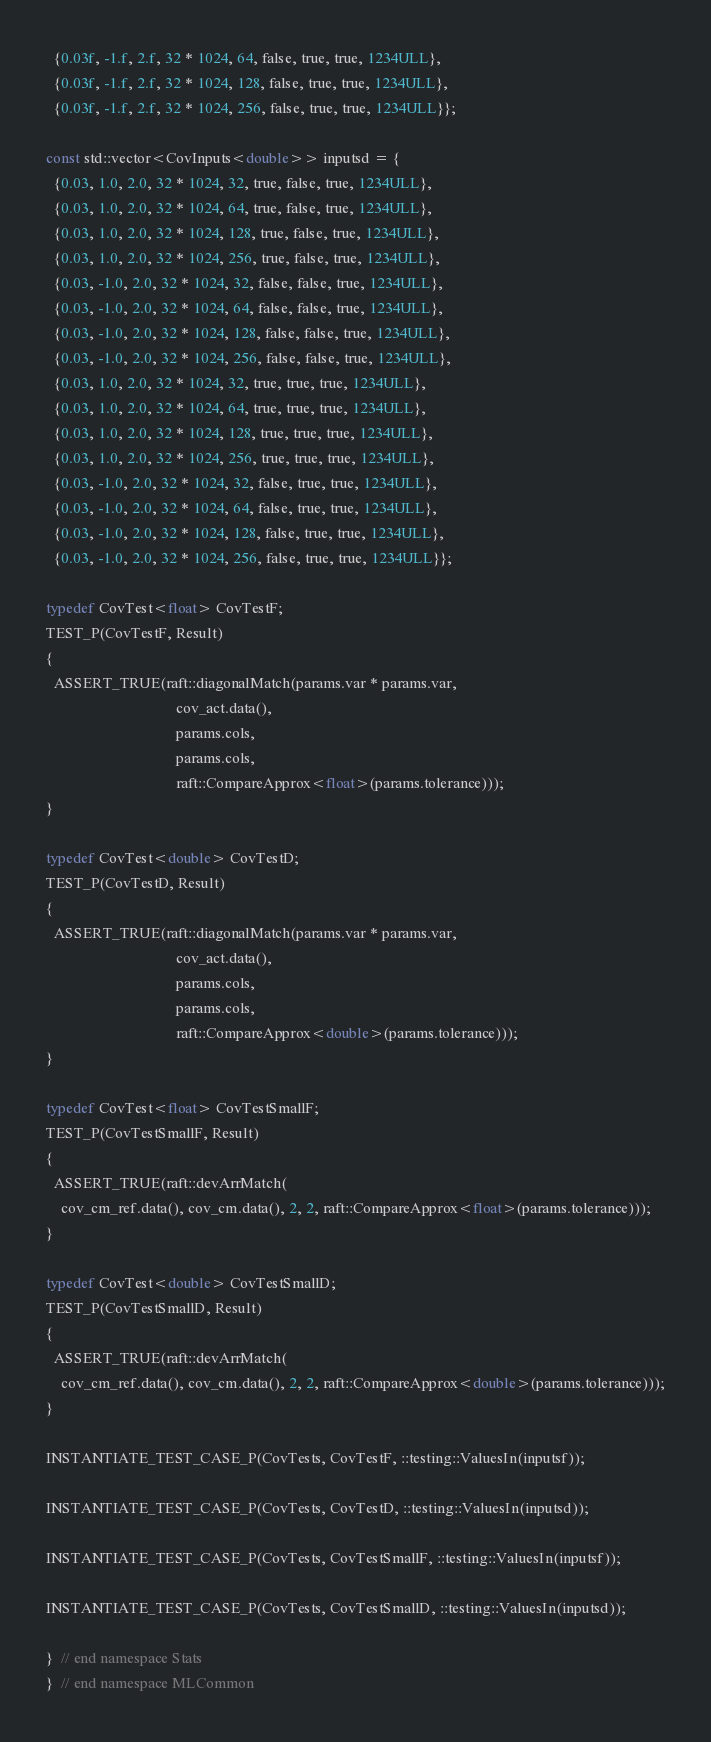<code> <loc_0><loc_0><loc_500><loc_500><_Cuda_>  {0.03f, -1.f, 2.f, 32 * 1024, 64, false, true, true, 1234ULL},
  {0.03f, -1.f, 2.f, 32 * 1024, 128, false, true, true, 1234ULL},
  {0.03f, -1.f, 2.f, 32 * 1024, 256, false, true, true, 1234ULL}};

const std::vector<CovInputs<double>> inputsd = {
  {0.03, 1.0, 2.0, 32 * 1024, 32, true, false, true, 1234ULL},
  {0.03, 1.0, 2.0, 32 * 1024, 64, true, false, true, 1234ULL},
  {0.03, 1.0, 2.0, 32 * 1024, 128, true, false, true, 1234ULL},
  {0.03, 1.0, 2.0, 32 * 1024, 256, true, false, true, 1234ULL},
  {0.03, -1.0, 2.0, 32 * 1024, 32, false, false, true, 1234ULL},
  {0.03, -1.0, 2.0, 32 * 1024, 64, false, false, true, 1234ULL},
  {0.03, -1.0, 2.0, 32 * 1024, 128, false, false, true, 1234ULL},
  {0.03, -1.0, 2.0, 32 * 1024, 256, false, false, true, 1234ULL},
  {0.03, 1.0, 2.0, 32 * 1024, 32, true, true, true, 1234ULL},
  {0.03, 1.0, 2.0, 32 * 1024, 64, true, true, true, 1234ULL},
  {0.03, 1.0, 2.0, 32 * 1024, 128, true, true, true, 1234ULL},
  {0.03, 1.0, 2.0, 32 * 1024, 256, true, true, true, 1234ULL},
  {0.03, -1.0, 2.0, 32 * 1024, 32, false, true, true, 1234ULL},
  {0.03, -1.0, 2.0, 32 * 1024, 64, false, true, true, 1234ULL},
  {0.03, -1.0, 2.0, 32 * 1024, 128, false, true, true, 1234ULL},
  {0.03, -1.0, 2.0, 32 * 1024, 256, false, true, true, 1234ULL}};

typedef CovTest<float> CovTestF;
TEST_P(CovTestF, Result)
{
  ASSERT_TRUE(raft::diagonalMatch(params.var * params.var,
                                  cov_act.data(),
                                  params.cols,
                                  params.cols,
                                  raft::CompareApprox<float>(params.tolerance)));
}

typedef CovTest<double> CovTestD;
TEST_P(CovTestD, Result)
{
  ASSERT_TRUE(raft::diagonalMatch(params.var * params.var,
                                  cov_act.data(),
                                  params.cols,
                                  params.cols,
                                  raft::CompareApprox<double>(params.tolerance)));
}

typedef CovTest<float> CovTestSmallF;
TEST_P(CovTestSmallF, Result)
{
  ASSERT_TRUE(raft::devArrMatch(
    cov_cm_ref.data(), cov_cm.data(), 2, 2, raft::CompareApprox<float>(params.tolerance)));
}

typedef CovTest<double> CovTestSmallD;
TEST_P(CovTestSmallD, Result)
{
  ASSERT_TRUE(raft::devArrMatch(
    cov_cm_ref.data(), cov_cm.data(), 2, 2, raft::CompareApprox<double>(params.tolerance)));
}

INSTANTIATE_TEST_CASE_P(CovTests, CovTestF, ::testing::ValuesIn(inputsf));

INSTANTIATE_TEST_CASE_P(CovTests, CovTestD, ::testing::ValuesIn(inputsd));

INSTANTIATE_TEST_CASE_P(CovTests, CovTestSmallF, ::testing::ValuesIn(inputsf));

INSTANTIATE_TEST_CASE_P(CovTests, CovTestSmallD, ::testing::ValuesIn(inputsd));

}  // end namespace Stats
}  // end namespace MLCommon
</code> 